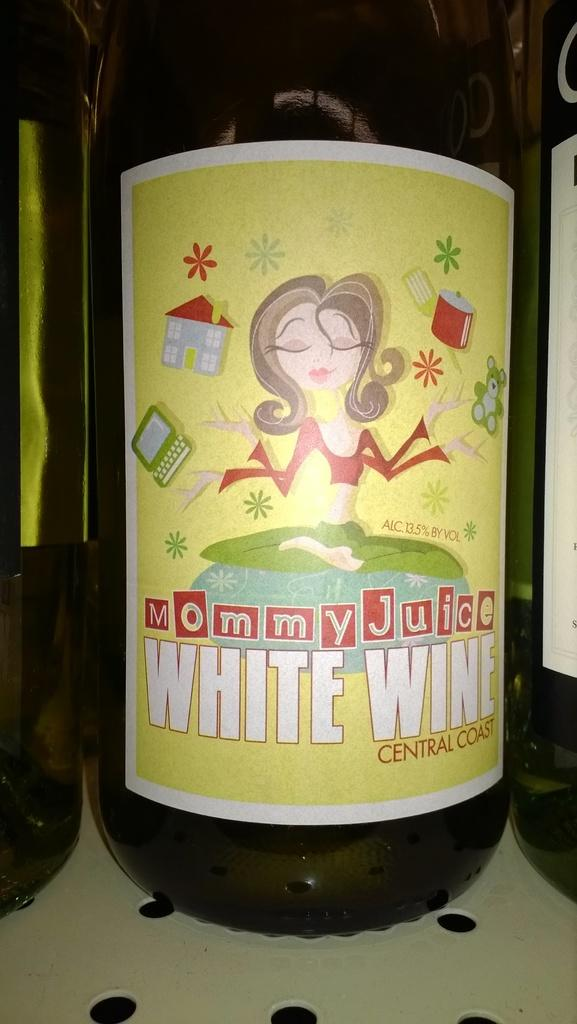<image>
Relay a brief, clear account of the picture shown. A bottle of Mommy Juice White Wine from the central coast. 